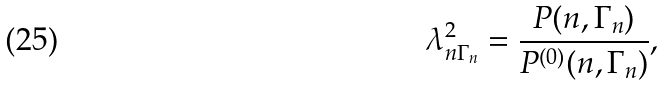<formula> <loc_0><loc_0><loc_500><loc_500>\lambda _ { n \Gamma _ { n } } ^ { 2 } = \frac { P ( n , \Gamma _ { n } ) } { P ^ { ( 0 ) } ( n , \Gamma _ { n } ) } ,</formula> 